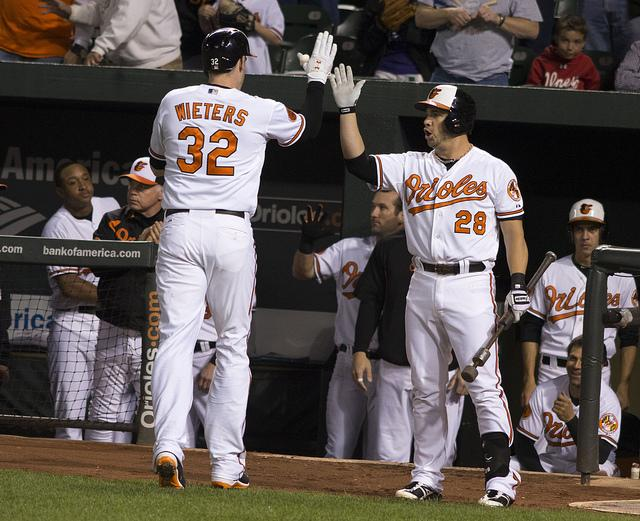What are the players here likely celebrating? run 